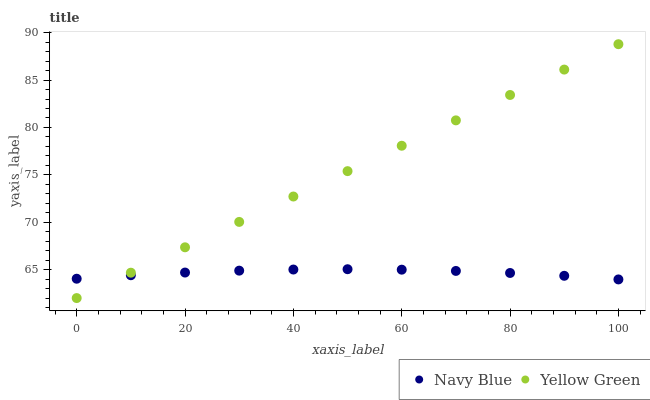Does Navy Blue have the minimum area under the curve?
Answer yes or no. Yes. Does Yellow Green have the maximum area under the curve?
Answer yes or no. Yes. Does Yellow Green have the minimum area under the curve?
Answer yes or no. No. Is Yellow Green the smoothest?
Answer yes or no. Yes. Is Navy Blue the roughest?
Answer yes or no. Yes. Is Yellow Green the roughest?
Answer yes or no. No. Does Yellow Green have the lowest value?
Answer yes or no. Yes. Does Yellow Green have the highest value?
Answer yes or no. Yes. Does Navy Blue intersect Yellow Green?
Answer yes or no. Yes. Is Navy Blue less than Yellow Green?
Answer yes or no. No. Is Navy Blue greater than Yellow Green?
Answer yes or no. No. 